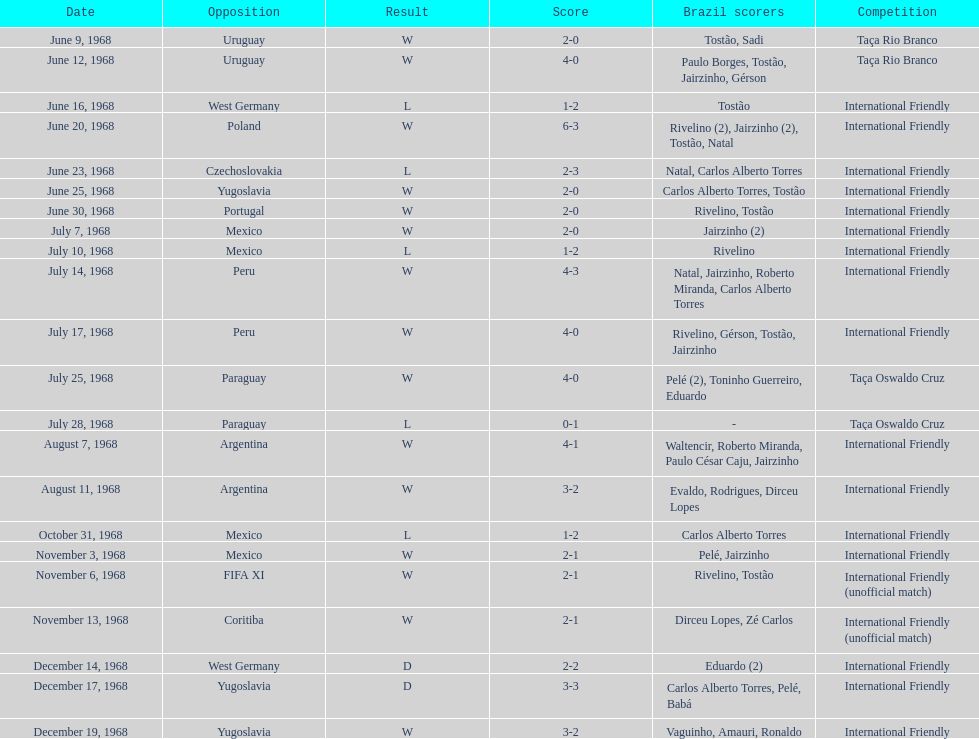What is the quantity of nations they have performed in? 11. Give me the full table as a dictionary. {'header': ['Date', 'Opposition', 'Result', 'Score', 'Brazil scorers', 'Competition'], 'rows': [['June 9, 1968', 'Uruguay', 'W', '2-0', 'Tostão, Sadi', 'Taça Rio Branco'], ['June 12, 1968', 'Uruguay', 'W', '4-0', 'Paulo Borges, Tostão, Jairzinho, Gérson', 'Taça Rio Branco'], ['June 16, 1968', 'West Germany', 'L', '1-2', 'Tostão', 'International Friendly'], ['June 20, 1968', 'Poland', 'W', '6-3', 'Rivelino (2), Jairzinho (2), Tostão, Natal', 'International Friendly'], ['June 23, 1968', 'Czechoslovakia', 'L', '2-3', 'Natal, Carlos Alberto Torres', 'International Friendly'], ['June 25, 1968', 'Yugoslavia', 'W', '2-0', 'Carlos Alberto Torres, Tostão', 'International Friendly'], ['June 30, 1968', 'Portugal', 'W', '2-0', 'Rivelino, Tostão', 'International Friendly'], ['July 7, 1968', 'Mexico', 'W', '2-0', 'Jairzinho (2)', 'International Friendly'], ['July 10, 1968', 'Mexico', 'L', '1-2', 'Rivelino', 'International Friendly'], ['July 14, 1968', 'Peru', 'W', '4-3', 'Natal, Jairzinho, Roberto Miranda, Carlos Alberto Torres', 'International Friendly'], ['July 17, 1968', 'Peru', 'W', '4-0', 'Rivelino, Gérson, Tostão, Jairzinho', 'International Friendly'], ['July 25, 1968', 'Paraguay', 'W', '4-0', 'Pelé (2), Toninho Guerreiro, Eduardo', 'Taça Oswaldo Cruz'], ['July 28, 1968', 'Paraguay', 'L', '0-1', '-', 'Taça Oswaldo Cruz'], ['August 7, 1968', 'Argentina', 'W', '4-1', 'Waltencir, Roberto Miranda, Paulo César Caju, Jairzinho', 'International Friendly'], ['August 11, 1968', 'Argentina', 'W', '3-2', 'Evaldo, Rodrigues, Dirceu Lopes', 'International Friendly'], ['October 31, 1968', 'Mexico', 'L', '1-2', 'Carlos Alberto Torres', 'International Friendly'], ['November 3, 1968', 'Mexico', 'W', '2-1', 'Pelé, Jairzinho', 'International Friendly'], ['November 6, 1968', 'FIFA XI', 'W', '2-1', 'Rivelino, Tostão', 'International Friendly (unofficial match)'], ['November 13, 1968', 'Coritiba', 'W', '2-1', 'Dirceu Lopes, Zé Carlos', 'International Friendly (unofficial match)'], ['December 14, 1968', 'West Germany', 'D', '2-2', 'Eduardo (2)', 'International Friendly'], ['December 17, 1968', 'Yugoslavia', 'D', '3-3', 'Carlos Alberto Torres, Pelé, Babá', 'International Friendly'], ['December 19, 1968', 'Yugoslavia', 'W', '3-2', 'Vaguinho, Amauri, Ronaldo', 'International Friendly']]} 